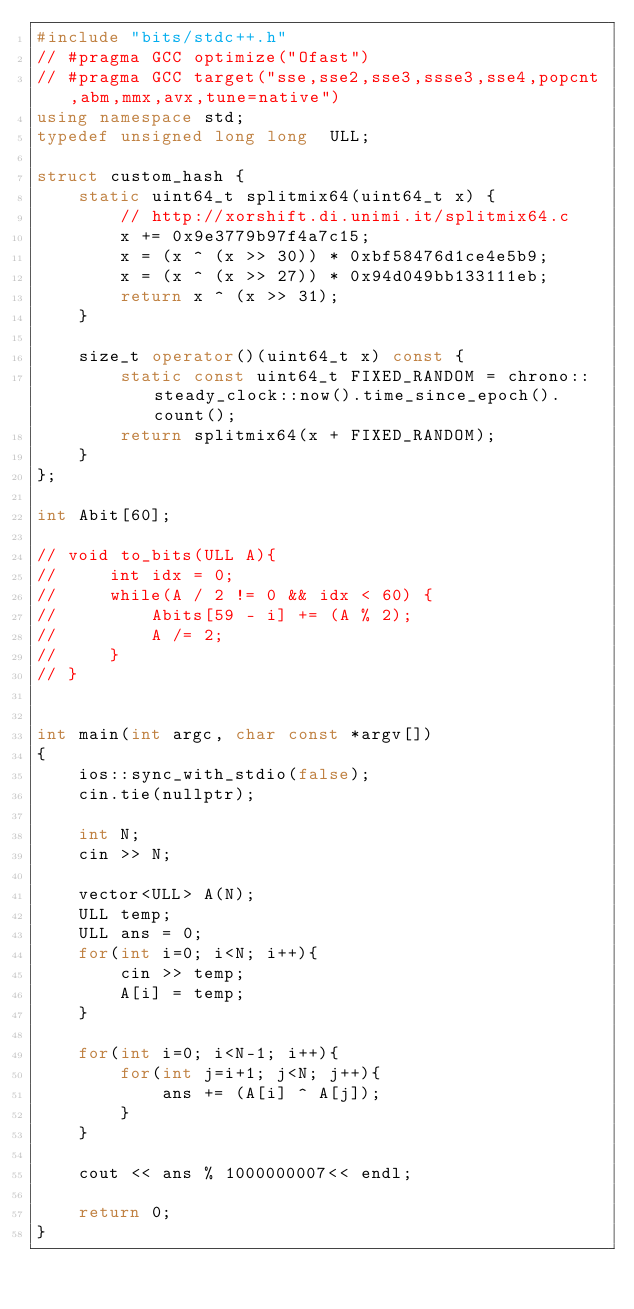<code> <loc_0><loc_0><loc_500><loc_500><_C++_>#include "bits/stdc++.h"
// #pragma GCC optimize("Ofast")
// #pragma GCC target("sse,sse2,sse3,ssse3,sse4,popcnt,abm,mmx,avx,tune=native")
using namespace std;
typedef unsigned long long  ULL;

struct custom_hash {
    static uint64_t splitmix64(uint64_t x) {
        // http://xorshift.di.unimi.it/splitmix64.c
        x += 0x9e3779b97f4a7c15;
        x = (x ^ (x >> 30)) * 0xbf58476d1ce4e5b9;
        x = (x ^ (x >> 27)) * 0x94d049bb133111eb;
        return x ^ (x >> 31);
    }

    size_t operator()(uint64_t x) const {
        static const uint64_t FIXED_RANDOM = chrono::steady_clock::now().time_since_epoch().count();
        return splitmix64(x + FIXED_RANDOM);
    }
};

int Abit[60];

// void to_bits(ULL A){
//     int idx = 0;
//     while(A / 2 != 0 && idx < 60) {
//         Abits[59 - i] += (A % 2);
//         A /= 2;
//     }
// }


int main(int argc, char const *argv[])
{
    ios::sync_with_stdio(false);
    cin.tie(nullptr);

    int N;
    cin >> N;

    vector<ULL> A(N);
    ULL temp;
    ULL ans = 0;
    for(int i=0; i<N; i++){
        cin >> temp;
        A[i] = temp;
    }

    for(int i=0; i<N-1; i++){
        for(int j=i+1; j<N; j++){
            ans += (A[i] ^ A[j]);
        }
    }

    cout << ans % 1000000007<< endl;

    return 0;
}
</code> 